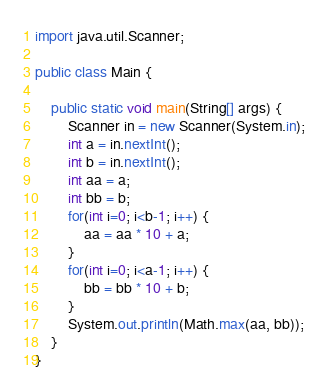Convert code to text. <code><loc_0><loc_0><loc_500><loc_500><_Java_>import java.util.Scanner;

public class Main {
	
	public static void main(String[] args) {
		Scanner in = new Scanner(System.in);
		int a = in.nextInt();
		int b = in.nextInt();
		int aa = a;
		int bb = b;
		for(int i=0; i<b-1; i++) {
			aa = aa * 10 + a;
		}
		for(int i=0; i<a-1; i++) {
			bb = bb * 10 + b;
		}
		System.out.println(Math.max(aa, bb));
	}
}</code> 